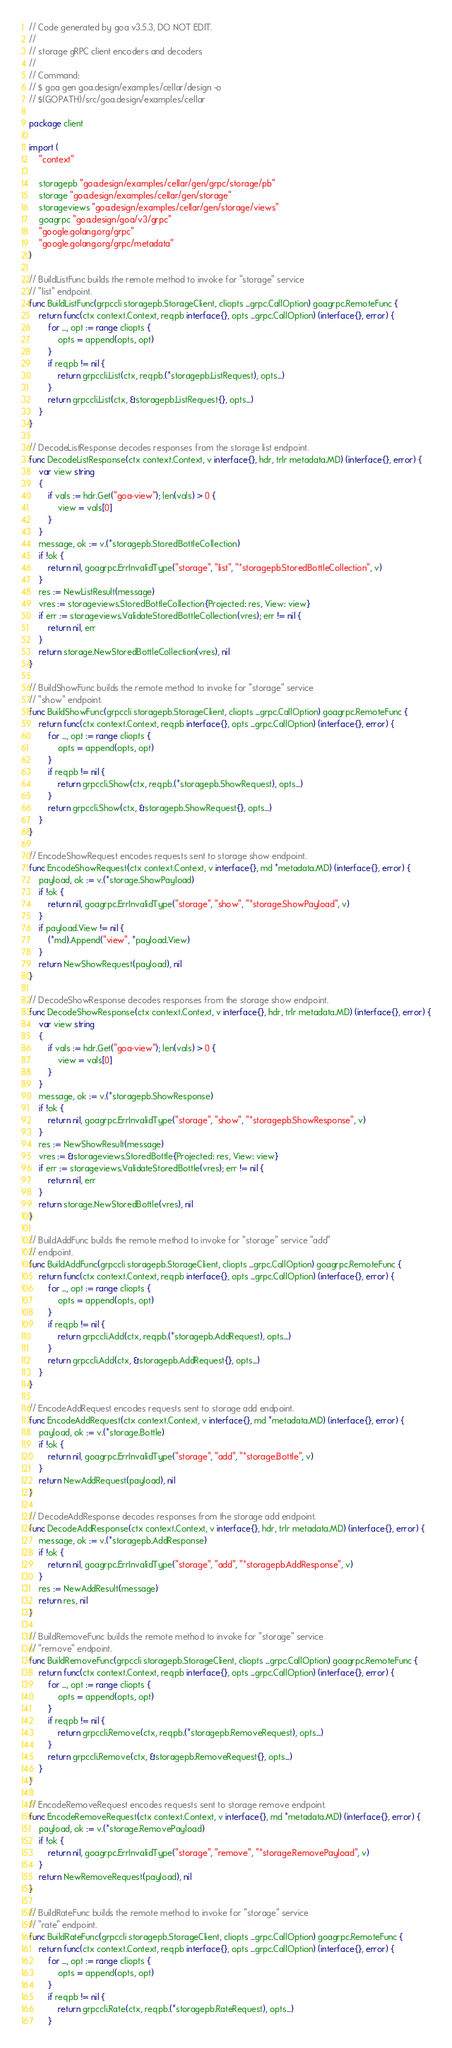Convert code to text. <code><loc_0><loc_0><loc_500><loc_500><_Go_>// Code generated by goa v3.5.3, DO NOT EDIT.
//
// storage gRPC client encoders and decoders
//
// Command:
// $ goa gen goa.design/examples/cellar/design -o
// $(GOPATH)/src/goa.design/examples/cellar

package client

import (
	"context"

	storagepb "goa.design/examples/cellar/gen/grpc/storage/pb"
	storage "goa.design/examples/cellar/gen/storage"
	storageviews "goa.design/examples/cellar/gen/storage/views"
	goagrpc "goa.design/goa/v3/grpc"
	"google.golang.org/grpc"
	"google.golang.org/grpc/metadata"
)

// BuildListFunc builds the remote method to invoke for "storage" service
// "list" endpoint.
func BuildListFunc(grpccli storagepb.StorageClient, cliopts ...grpc.CallOption) goagrpc.RemoteFunc {
	return func(ctx context.Context, reqpb interface{}, opts ...grpc.CallOption) (interface{}, error) {
		for _, opt := range cliopts {
			opts = append(opts, opt)
		}
		if reqpb != nil {
			return grpccli.List(ctx, reqpb.(*storagepb.ListRequest), opts...)
		}
		return grpccli.List(ctx, &storagepb.ListRequest{}, opts...)
	}
}

// DecodeListResponse decodes responses from the storage list endpoint.
func DecodeListResponse(ctx context.Context, v interface{}, hdr, trlr metadata.MD) (interface{}, error) {
	var view string
	{
		if vals := hdr.Get("goa-view"); len(vals) > 0 {
			view = vals[0]
		}
	}
	message, ok := v.(*storagepb.StoredBottleCollection)
	if !ok {
		return nil, goagrpc.ErrInvalidType("storage", "list", "*storagepb.StoredBottleCollection", v)
	}
	res := NewListResult(message)
	vres := storageviews.StoredBottleCollection{Projected: res, View: view}
	if err := storageviews.ValidateStoredBottleCollection(vres); err != nil {
		return nil, err
	}
	return storage.NewStoredBottleCollection(vres), nil
}

// BuildShowFunc builds the remote method to invoke for "storage" service
// "show" endpoint.
func BuildShowFunc(grpccli storagepb.StorageClient, cliopts ...grpc.CallOption) goagrpc.RemoteFunc {
	return func(ctx context.Context, reqpb interface{}, opts ...grpc.CallOption) (interface{}, error) {
		for _, opt := range cliopts {
			opts = append(opts, opt)
		}
		if reqpb != nil {
			return grpccli.Show(ctx, reqpb.(*storagepb.ShowRequest), opts...)
		}
		return grpccli.Show(ctx, &storagepb.ShowRequest{}, opts...)
	}
}

// EncodeShowRequest encodes requests sent to storage show endpoint.
func EncodeShowRequest(ctx context.Context, v interface{}, md *metadata.MD) (interface{}, error) {
	payload, ok := v.(*storage.ShowPayload)
	if !ok {
		return nil, goagrpc.ErrInvalidType("storage", "show", "*storage.ShowPayload", v)
	}
	if payload.View != nil {
		(*md).Append("view", *payload.View)
	}
	return NewShowRequest(payload), nil
}

// DecodeShowResponse decodes responses from the storage show endpoint.
func DecodeShowResponse(ctx context.Context, v interface{}, hdr, trlr metadata.MD) (interface{}, error) {
	var view string
	{
		if vals := hdr.Get("goa-view"); len(vals) > 0 {
			view = vals[0]
		}
	}
	message, ok := v.(*storagepb.ShowResponse)
	if !ok {
		return nil, goagrpc.ErrInvalidType("storage", "show", "*storagepb.ShowResponse", v)
	}
	res := NewShowResult(message)
	vres := &storageviews.StoredBottle{Projected: res, View: view}
	if err := storageviews.ValidateStoredBottle(vres); err != nil {
		return nil, err
	}
	return storage.NewStoredBottle(vres), nil
}

// BuildAddFunc builds the remote method to invoke for "storage" service "add"
// endpoint.
func BuildAddFunc(grpccli storagepb.StorageClient, cliopts ...grpc.CallOption) goagrpc.RemoteFunc {
	return func(ctx context.Context, reqpb interface{}, opts ...grpc.CallOption) (interface{}, error) {
		for _, opt := range cliopts {
			opts = append(opts, opt)
		}
		if reqpb != nil {
			return grpccli.Add(ctx, reqpb.(*storagepb.AddRequest), opts...)
		}
		return grpccli.Add(ctx, &storagepb.AddRequest{}, opts...)
	}
}

// EncodeAddRequest encodes requests sent to storage add endpoint.
func EncodeAddRequest(ctx context.Context, v interface{}, md *metadata.MD) (interface{}, error) {
	payload, ok := v.(*storage.Bottle)
	if !ok {
		return nil, goagrpc.ErrInvalidType("storage", "add", "*storage.Bottle", v)
	}
	return NewAddRequest(payload), nil
}

// DecodeAddResponse decodes responses from the storage add endpoint.
func DecodeAddResponse(ctx context.Context, v interface{}, hdr, trlr metadata.MD) (interface{}, error) {
	message, ok := v.(*storagepb.AddResponse)
	if !ok {
		return nil, goagrpc.ErrInvalidType("storage", "add", "*storagepb.AddResponse", v)
	}
	res := NewAddResult(message)
	return res, nil
}

// BuildRemoveFunc builds the remote method to invoke for "storage" service
// "remove" endpoint.
func BuildRemoveFunc(grpccli storagepb.StorageClient, cliopts ...grpc.CallOption) goagrpc.RemoteFunc {
	return func(ctx context.Context, reqpb interface{}, opts ...grpc.CallOption) (interface{}, error) {
		for _, opt := range cliopts {
			opts = append(opts, opt)
		}
		if reqpb != nil {
			return grpccli.Remove(ctx, reqpb.(*storagepb.RemoveRequest), opts...)
		}
		return grpccli.Remove(ctx, &storagepb.RemoveRequest{}, opts...)
	}
}

// EncodeRemoveRequest encodes requests sent to storage remove endpoint.
func EncodeRemoveRequest(ctx context.Context, v interface{}, md *metadata.MD) (interface{}, error) {
	payload, ok := v.(*storage.RemovePayload)
	if !ok {
		return nil, goagrpc.ErrInvalidType("storage", "remove", "*storage.RemovePayload", v)
	}
	return NewRemoveRequest(payload), nil
}

// BuildRateFunc builds the remote method to invoke for "storage" service
// "rate" endpoint.
func BuildRateFunc(grpccli storagepb.StorageClient, cliopts ...grpc.CallOption) goagrpc.RemoteFunc {
	return func(ctx context.Context, reqpb interface{}, opts ...grpc.CallOption) (interface{}, error) {
		for _, opt := range cliopts {
			opts = append(opts, opt)
		}
		if reqpb != nil {
			return grpccli.Rate(ctx, reqpb.(*storagepb.RateRequest), opts...)
		}</code> 